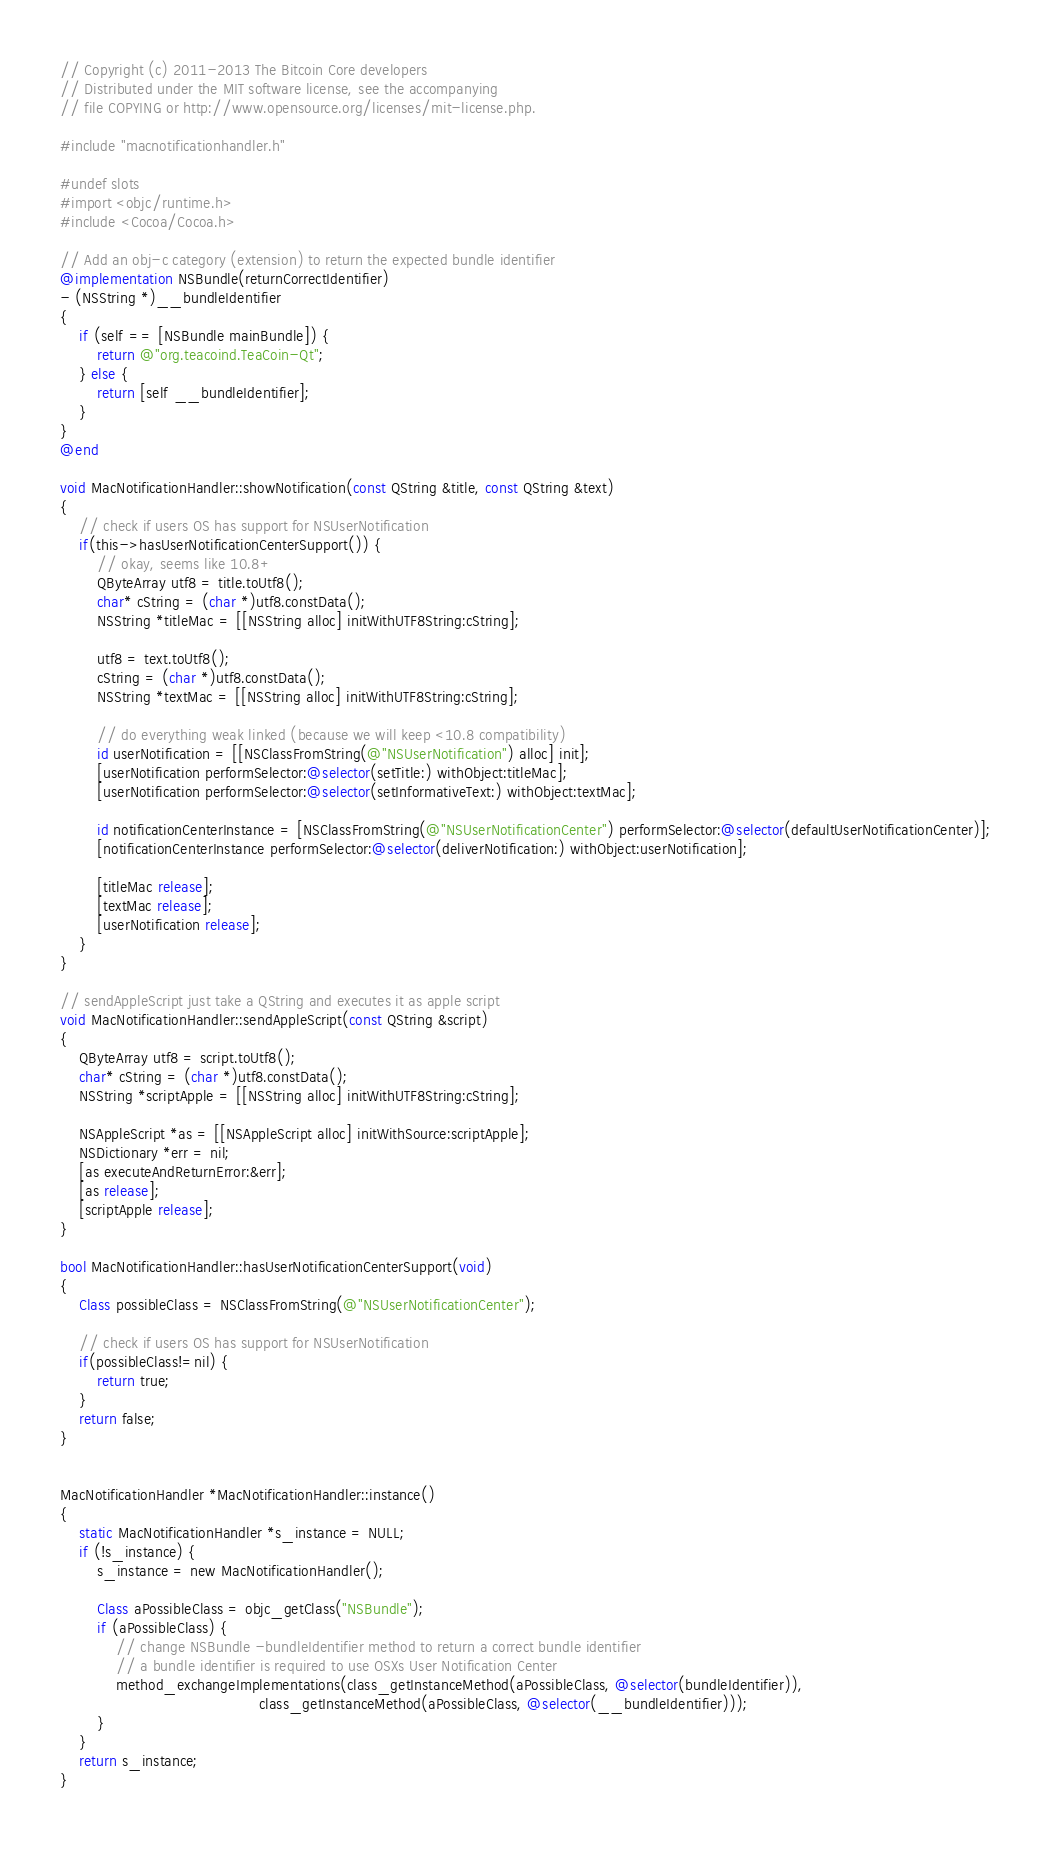<code> <loc_0><loc_0><loc_500><loc_500><_ObjectiveC_>// Copyright (c) 2011-2013 The Bitcoin Core developers
// Distributed under the MIT software license, see the accompanying
// file COPYING or http://www.opensource.org/licenses/mit-license.php.

#include "macnotificationhandler.h"

#undef slots
#import <objc/runtime.h>
#include <Cocoa/Cocoa.h>

// Add an obj-c category (extension) to return the expected bundle identifier
@implementation NSBundle(returnCorrectIdentifier)
- (NSString *)__bundleIdentifier
{
    if (self == [NSBundle mainBundle]) {
        return @"org.teacoind.TeaCoin-Qt";
    } else {
        return [self __bundleIdentifier];
    }
}
@end

void MacNotificationHandler::showNotification(const QString &title, const QString &text)
{
    // check if users OS has support for NSUserNotification
    if(this->hasUserNotificationCenterSupport()) {
        // okay, seems like 10.8+
        QByteArray utf8 = title.toUtf8();
        char* cString = (char *)utf8.constData();
        NSString *titleMac = [[NSString alloc] initWithUTF8String:cString];

        utf8 = text.toUtf8();
        cString = (char *)utf8.constData();
        NSString *textMac = [[NSString alloc] initWithUTF8String:cString];

        // do everything weak linked (because we will keep <10.8 compatibility)
        id userNotification = [[NSClassFromString(@"NSUserNotification") alloc] init];
        [userNotification performSelector:@selector(setTitle:) withObject:titleMac];
        [userNotification performSelector:@selector(setInformativeText:) withObject:textMac];

        id notificationCenterInstance = [NSClassFromString(@"NSUserNotificationCenter") performSelector:@selector(defaultUserNotificationCenter)];
        [notificationCenterInstance performSelector:@selector(deliverNotification:) withObject:userNotification];

        [titleMac release];
        [textMac release];
        [userNotification release];
    }
}

// sendAppleScript just take a QString and executes it as apple script
void MacNotificationHandler::sendAppleScript(const QString &script)
{
    QByteArray utf8 = script.toUtf8();
    char* cString = (char *)utf8.constData();
    NSString *scriptApple = [[NSString alloc] initWithUTF8String:cString];

    NSAppleScript *as = [[NSAppleScript alloc] initWithSource:scriptApple];
    NSDictionary *err = nil;
    [as executeAndReturnError:&err];
    [as release];
    [scriptApple release];
}

bool MacNotificationHandler::hasUserNotificationCenterSupport(void)
{
    Class possibleClass = NSClassFromString(@"NSUserNotificationCenter");

    // check if users OS has support for NSUserNotification
    if(possibleClass!=nil) {
        return true;
    }
    return false;
}


MacNotificationHandler *MacNotificationHandler::instance()
{
    static MacNotificationHandler *s_instance = NULL;
    if (!s_instance) {
        s_instance = new MacNotificationHandler();
        
        Class aPossibleClass = objc_getClass("NSBundle");
        if (aPossibleClass) {
            // change NSBundle -bundleIdentifier method to return a correct bundle identifier
            // a bundle identifier is required to use OSXs User Notification Center
            method_exchangeImplementations(class_getInstanceMethod(aPossibleClass, @selector(bundleIdentifier)),
                                           class_getInstanceMethod(aPossibleClass, @selector(__bundleIdentifier)));
        }
    }
    return s_instance;
}
</code> 